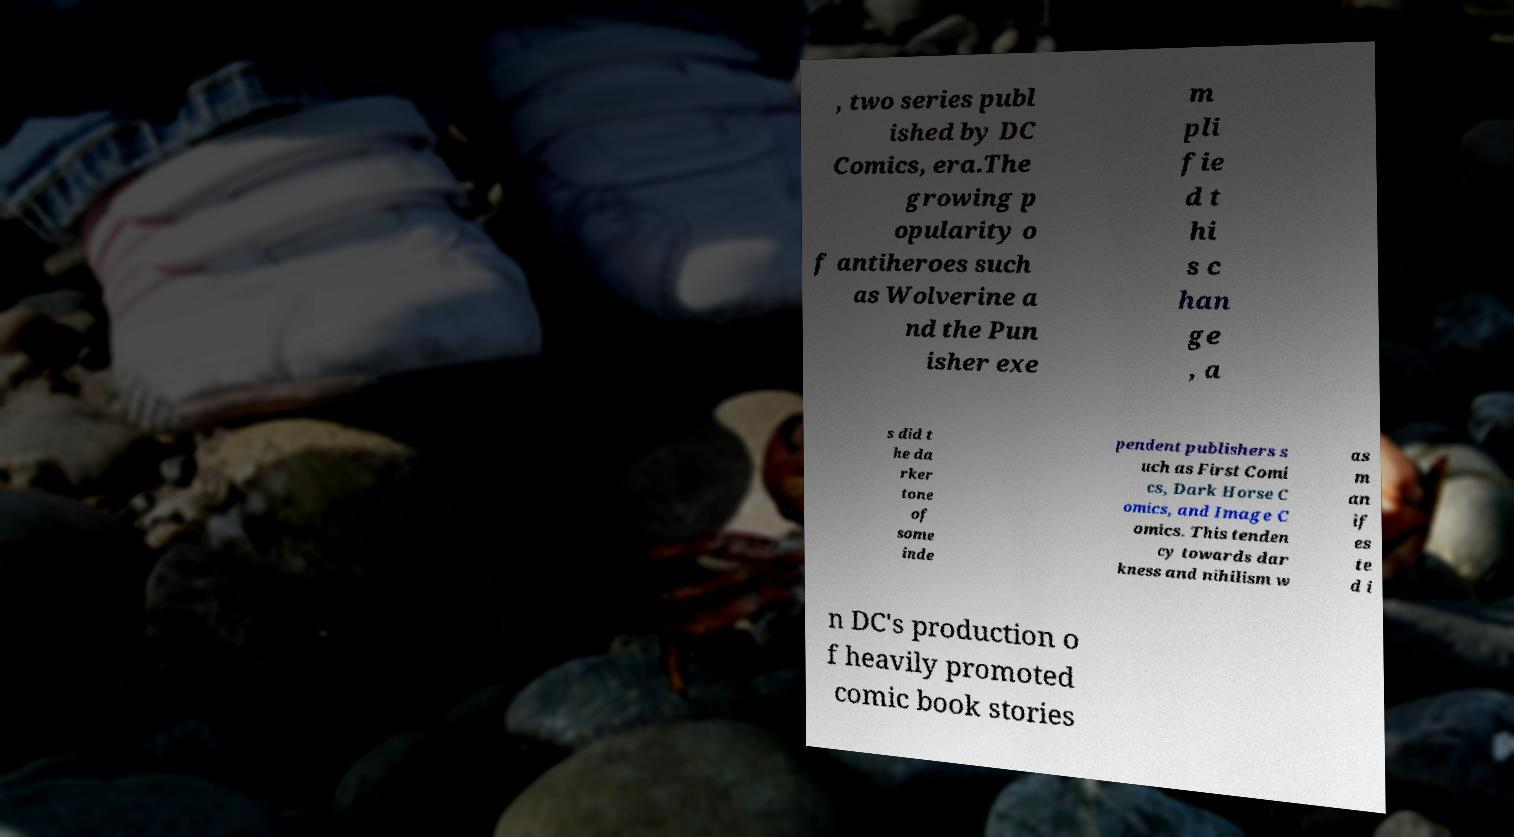Can you read and provide the text displayed in the image?This photo seems to have some interesting text. Can you extract and type it out for me? , two series publ ished by DC Comics, era.The growing p opularity o f antiheroes such as Wolverine a nd the Pun isher exe m pli fie d t hi s c han ge , a s did t he da rker tone of some inde pendent publishers s uch as First Comi cs, Dark Horse C omics, and Image C omics. This tenden cy towards dar kness and nihilism w as m an if es te d i n DC's production o f heavily promoted comic book stories 